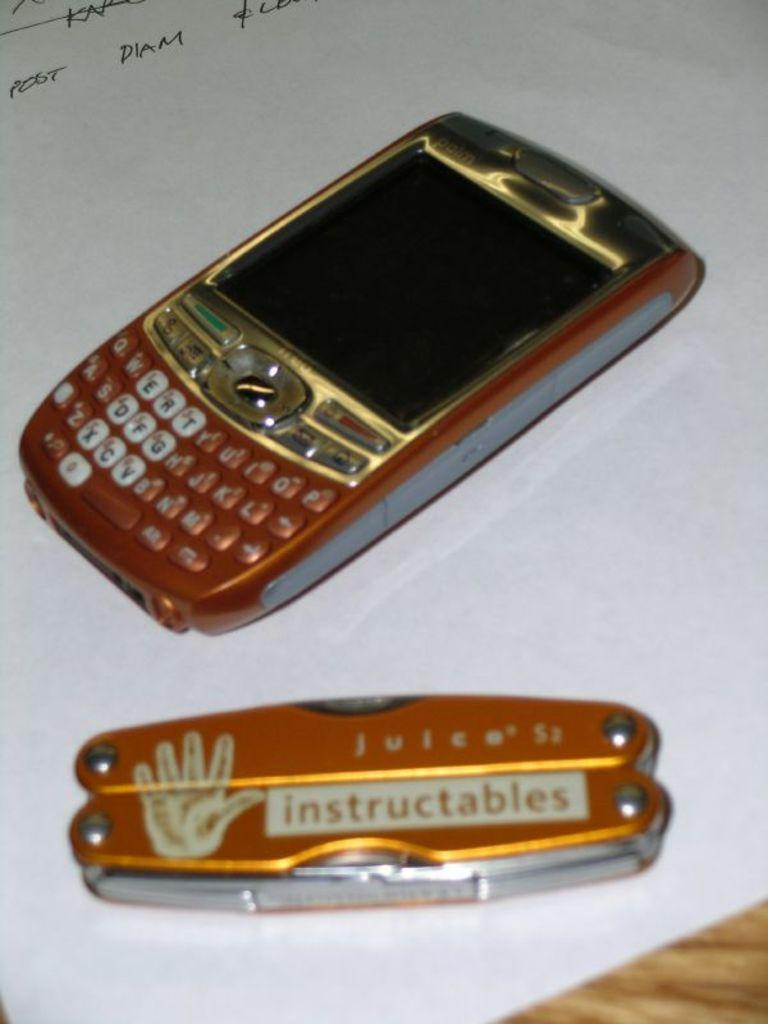Provide a one-sentence caption for the provided image. A burnt orange colored Blackberry phone is next to a pocket knife of the same color with the words instructables on it. 